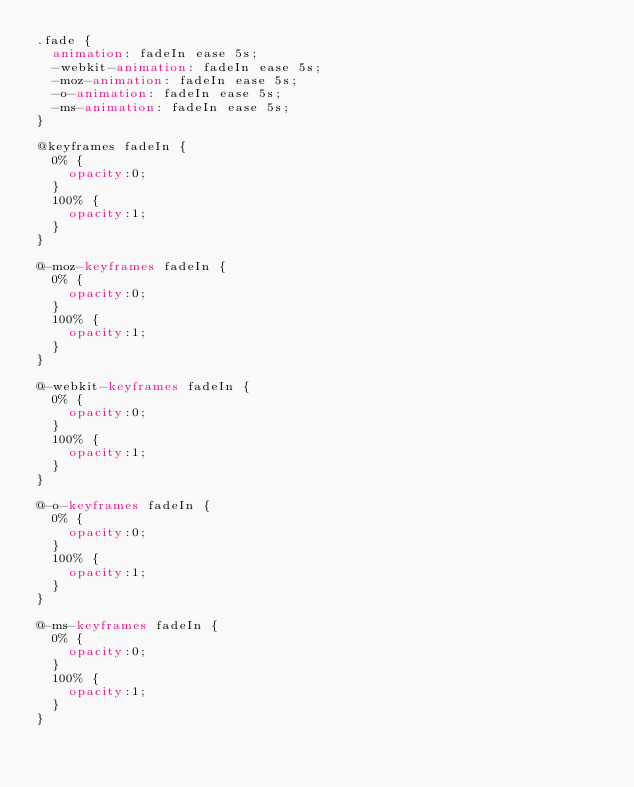<code> <loc_0><loc_0><loc_500><loc_500><_CSS_>.fade {
  animation: fadeIn ease 5s;
  -webkit-animation: fadeIn ease 5s;
  -moz-animation: fadeIn ease 5s;
  -o-animation: fadeIn ease 5s;
  -ms-animation: fadeIn ease 5s;
}

@keyframes fadeIn {
  0% {
    opacity:0;
  }
  100% {
    opacity:1;
  }
}

@-moz-keyframes fadeIn {
  0% {
    opacity:0;
  }
  100% {
    opacity:1;
  }
}

@-webkit-keyframes fadeIn {
  0% {
    opacity:0;
  }
  100% {
    opacity:1;
  }
}

@-o-keyframes fadeIn {
  0% {
    opacity:0;
  }
  100% {
    opacity:1;
  }
}

@-ms-keyframes fadeIn {
  0% {
    opacity:0;
  }
  100% {
    opacity:1;
  }
}</code> 